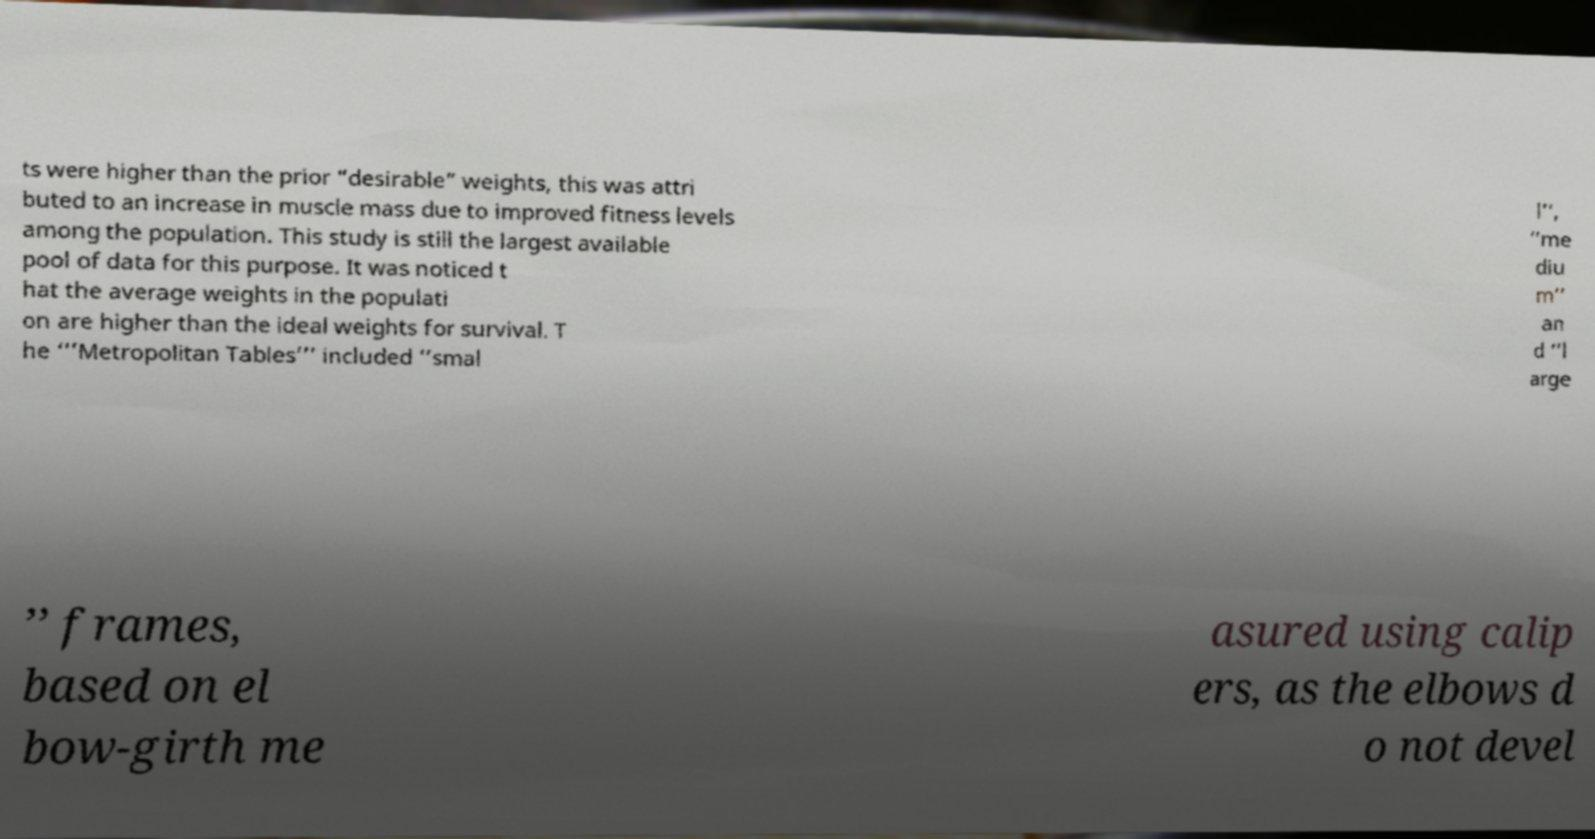Can you accurately transcribe the text from the provided image for me? ts were higher than the prior “desirable” weights, this was attri buted to an increase in muscle mass due to improved fitness levels among the population. This study is still the largest available pool of data for this purpose. It was noticed t hat the average weights in the populati on are higher than the ideal weights for survival. T he ‘’’Metropolitan Tables’’’ included ‘’smal l’’, ‘’me diu m’’ an d ‘’l arge ’’ frames, based on el bow-girth me asured using calip ers, as the elbows d o not devel 